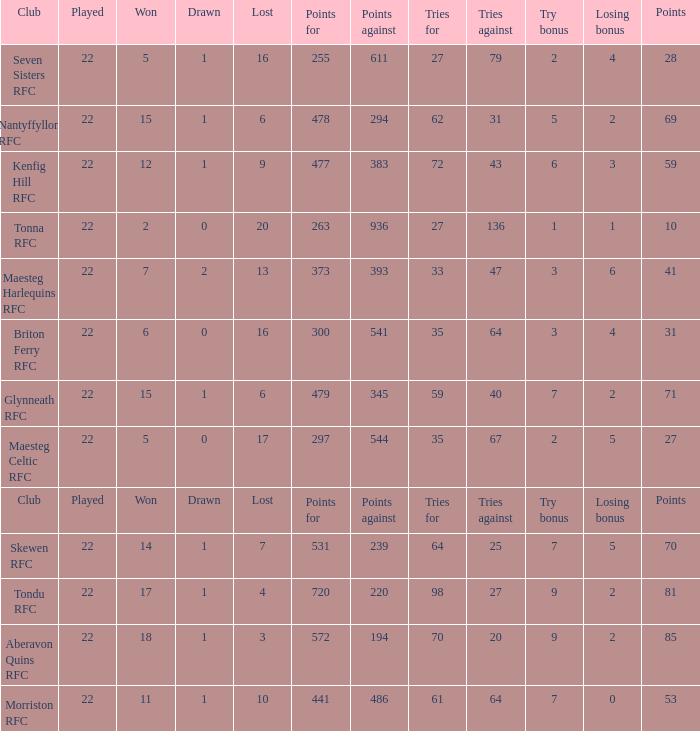What is the value of the points column when the value of the column lost is "lost" Points. 